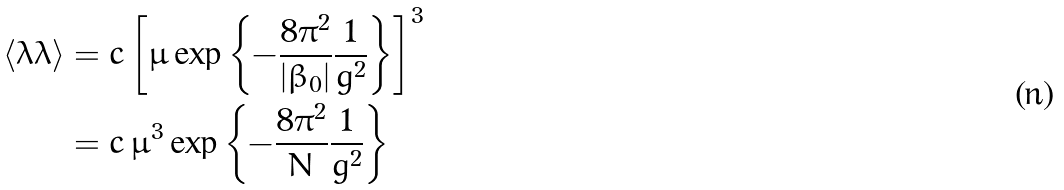<formula> <loc_0><loc_0><loc_500><loc_500>\left \langle \lambda \lambda \right \rangle & = c \left [ \mu \exp \left \{ - \frac { 8 \pi ^ { 2 } } { | \beta _ { 0 } | } \frac { 1 } { g ^ { 2 } } \right \} \right ] ^ { 3 } \\ & = c \, \mu ^ { 3 } \exp \left \{ - \frac { 8 \pi ^ { 2 } } { N } \frac { 1 } { g ^ { 2 } } \right \}</formula> 